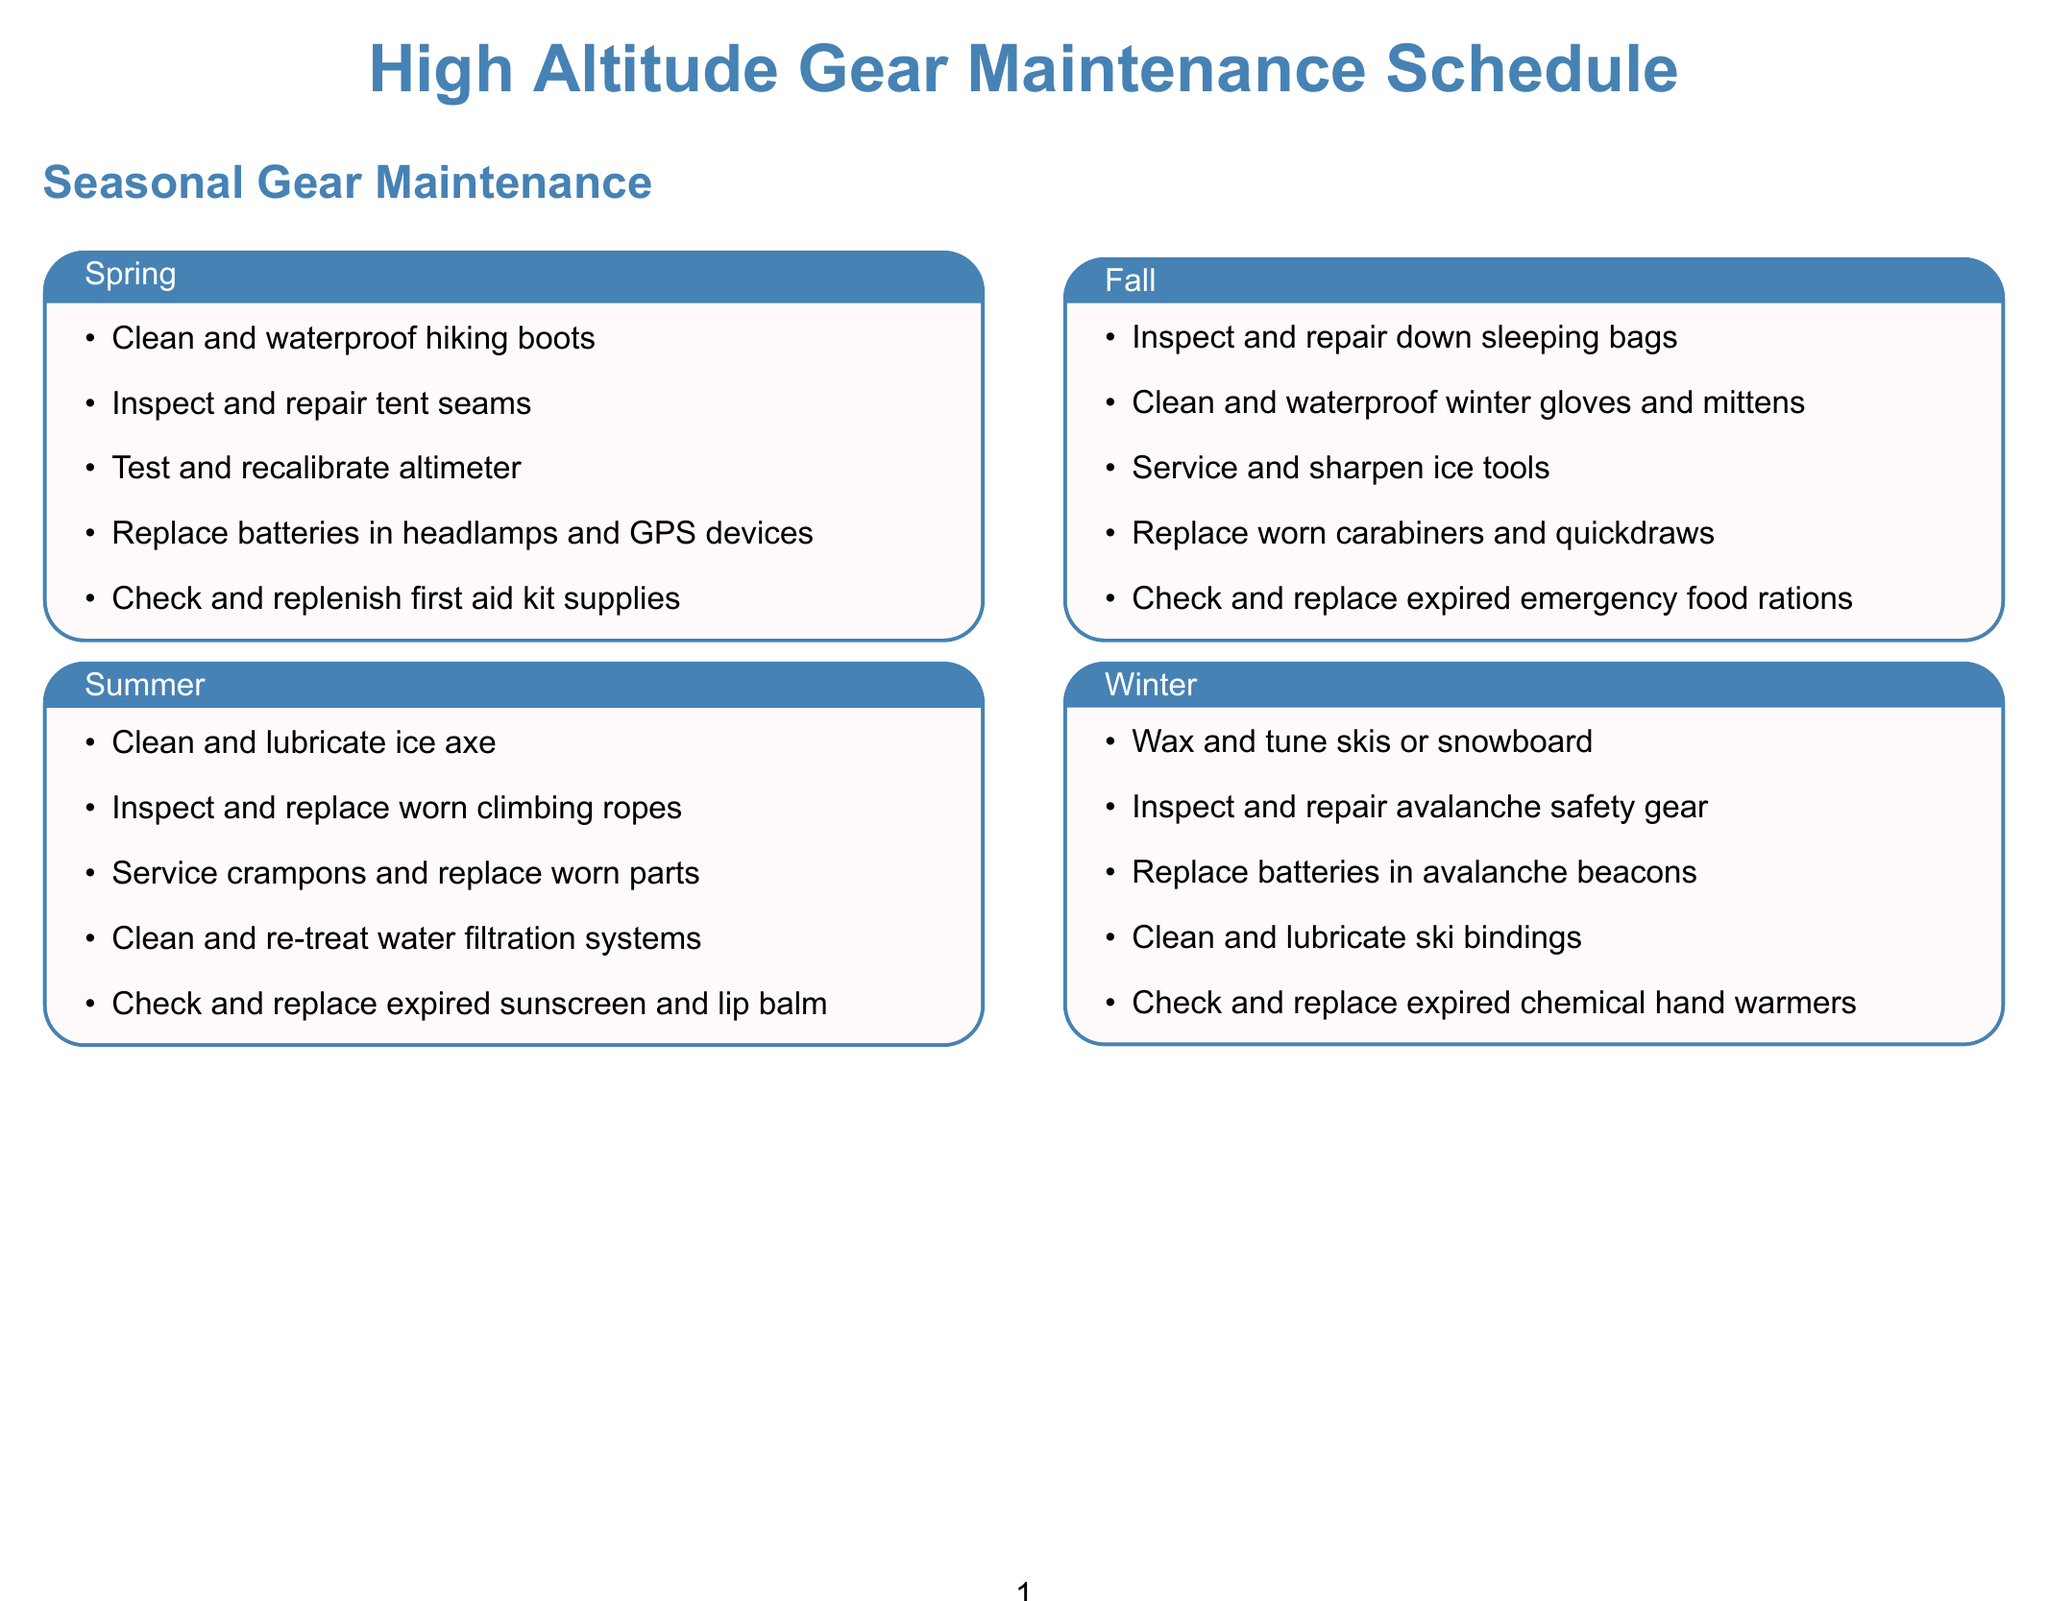What maintenance task is scheduled for Spring? The document lists specific maintenance tasks for each season, and for Spring, the tasks include cleaning and waterproofing hiking boots.
Answer: Clean and waterproof hiking boots What is the replacement interval for the Black Diamond Momentum climbing harness? The document specifies the replacement interval for various gear items, stating that the Black Diamond Momentum climbing harness should be replaced every 3-5 years or sooner if visible wear.
Answer: Every 3-5 years or sooner if visible wear How long do Datrex emergency water pouches last? The document provides expiration dates for emergency supplies, noting that Datrex emergency water pouches last for 5 years from the manufacture date.
Answer: 5 years from manufacture date What maintenance should be done for the Gamow bag? The document outlines specific maintenance actions for high altitude gear, including inspecting for leaks and testing inflation monthly for the Gamow bag.
Answer: Inspect for leaks and test inflation monthly When should the batteries in the pulse oximeter be replaced? The document states that the pulse oximeter requires battery replacement before each expedition, indicating a critical maintenance practice.
Answer: Before each expedition What item has the longest expiration date? The document lists several emergency supplies and their expiration dates, with the Mountain House freeze-dried meals lasting 25-30 years from the manufacture date, making it the item with the longest expiration.
Answer: 25-30 years from manufacture date How often should insulated water bottles be maintained? The document details maintenance for high altitude specific items, stating that insulated water bottles require gasket replacement annually and inspection for cracks before each trip.
Answer: Annually What is the maintenance task for high-altitude tents? The document describes that high-altitude tents need to be cleaned and re-waterproofed annually and guy lines replaced every 2 years.
Answer: Clean and re-waterproof annually, replace guy lines every 2 years 